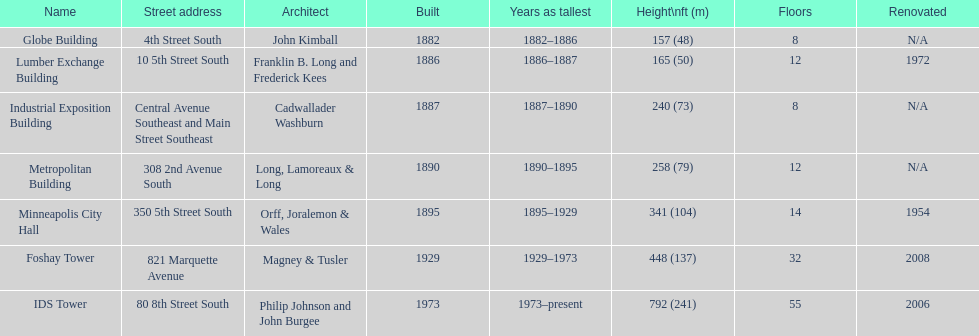Which building has 8 floors and is 240 ft tall? Industrial Exposition Building. Would you mind parsing the complete table? {'header': ['Name', 'Street address', 'Architect', 'Built', 'Years as tallest', 'Height\\nft (m)', 'Floors', 'Renovated'], 'rows': [['Globe Building', '4th Street South', 'John Kimball', '1882', '1882–1886', '157 (48)', '8', 'N/A'], ['Lumber Exchange Building', '10 5th Street South', 'Franklin B. Long and Frederick Kees', '1886', '1886–1887', '165 (50)', '12', '1972'], ['Industrial Exposition Building', 'Central Avenue Southeast and Main Street Southeast', 'Cadwallader Washburn', '1887', '1887–1890', '240 (73)', '8', 'N/A'], ['Metropolitan Building', '308 2nd Avenue South', 'Long, Lamoreaux & Long', '1890', '1890–1895', '258 (79)', '12', 'N/A'], ['Minneapolis City Hall', '350 5th Street South', 'Orff, Joralemon & Wales', '1895', '1895–1929', '341 (104)', '14', '1954'], ['Foshay Tower', '821 Marquette Avenue', 'Magney & Tusler', '1929', '1929–1973', '448 (137)', '32', '2008'], ['IDS Tower', '80 8th Street South', 'Philip Johnson and John Burgee', '1973', '1973–present', '792 (241)', '55', '2006']]} 